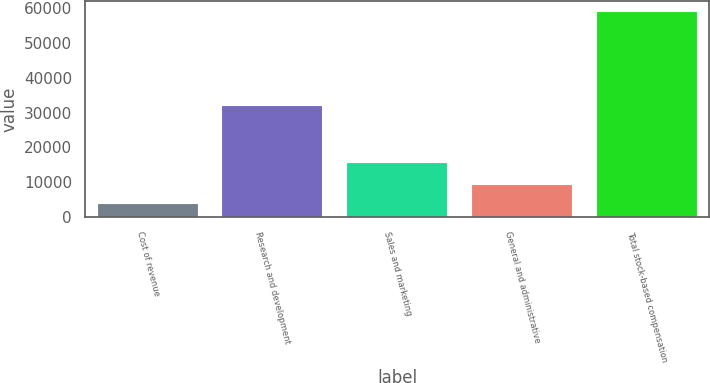Convert chart to OTSL. <chart><loc_0><loc_0><loc_500><loc_500><bar_chart><fcel>Cost of revenue<fcel>Research and development<fcel>Sales and marketing<fcel>General and administrative<fcel>Total stock-based compensation<nl><fcel>3620<fcel>31892<fcel>15666<fcel>9161.2<fcel>59032<nl></chart> 